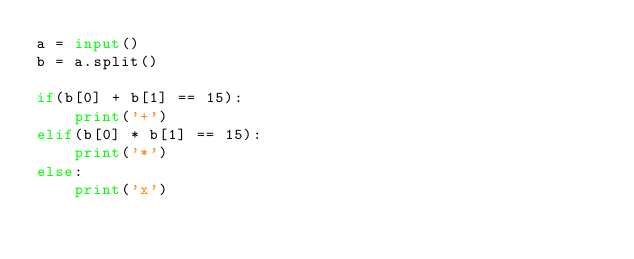<code> <loc_0><loc_0><loc_500><loc_500><_Python_>a = input()
b = a.split()

if(b[0] + b[1] == 15):
    print('+')
elif(b[0] * b[1] == 15):
    print('*')
else:
    print('x')</code> 